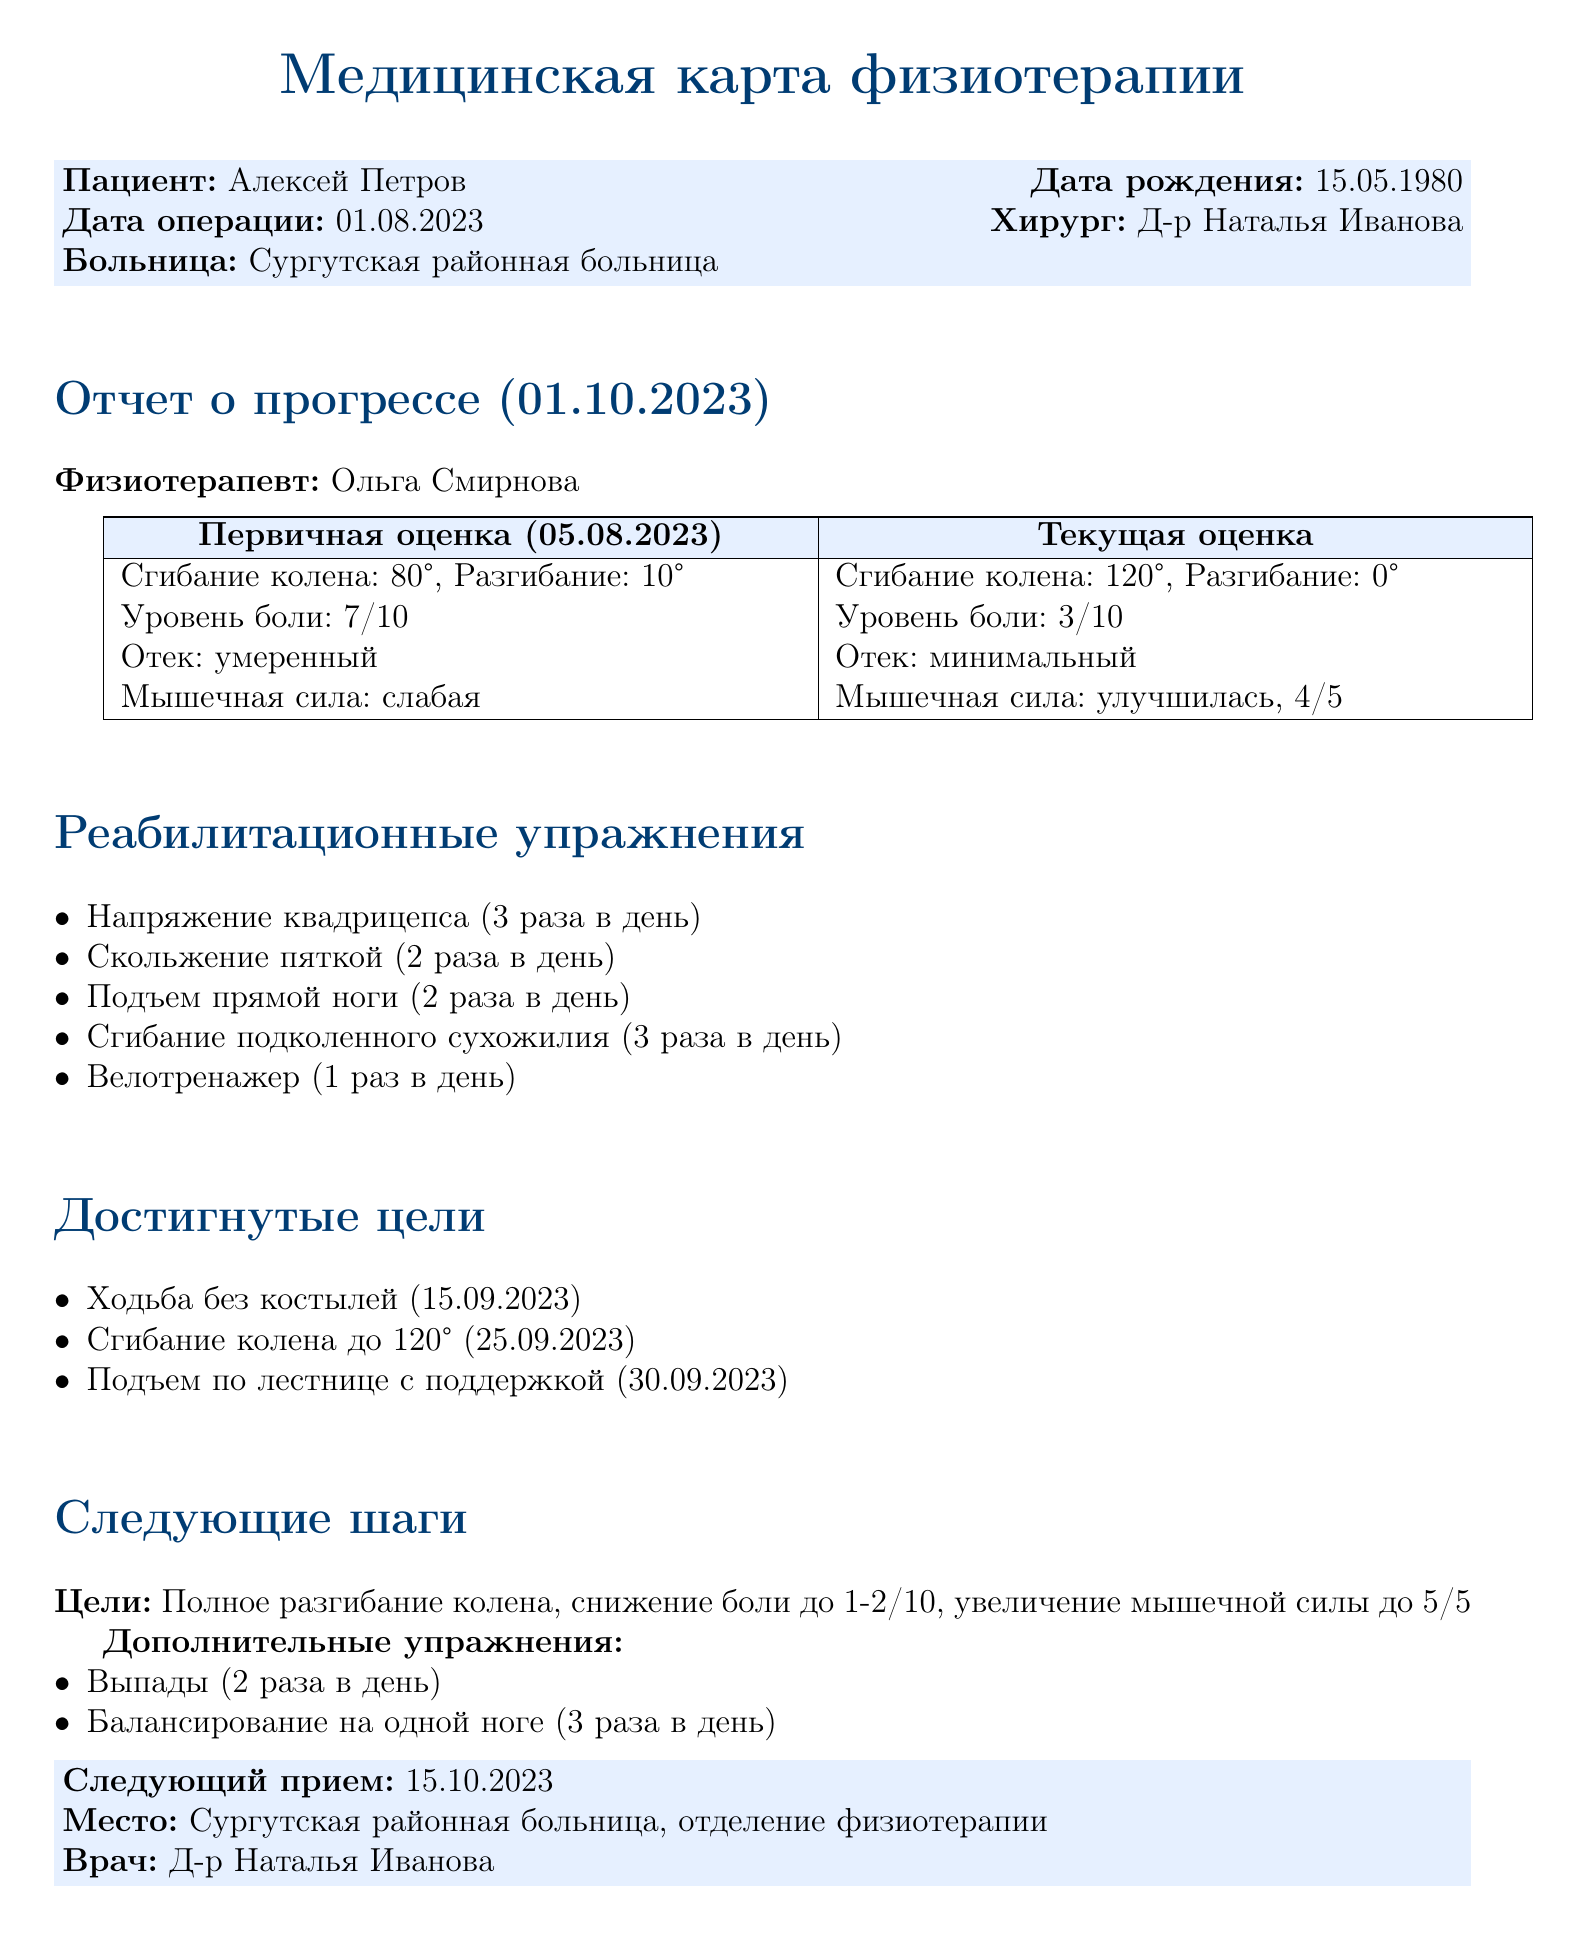Что имя пациента? Имя пациента указано в блоке с информацией о пациенте.
Answer: Алексей Петров Какова дата операции? Дата операции указана в информации о пациенте.
Answer: 01.08.2023 Какой хирург выполнил операцию? Имя хирурга указано в блоке с информацией о пациенте.
Answer: Д-р Наталья Иванова Каков уровень боли на текущей оценке? Уровень боли на текущей оценке указан в таблице.
Answer: 3/10 Какие два новых упражнения добавлены в следующие шаги? Новые упражнения указаны в разделе "Дополнительные упражнения".
Answer: Выпады, Балансирование на одной ноге Какова цель по разгибанию колена? Цель по разгибанию колена указана в разделе "Следующие шаги".
Answer: Полное разгибание колена Когда была достигнута цель по сгибанию колена до 120°? Дата достижения цели указана в разделе "Достигнутые цели".
Answer: 25.09.2023 Какова текущая мышечная сила пациента? Текущая мышечная сила указана в таблице.
Answer: 4/5 Какой следующий приём? Информация о следующем приёме указана в блоке с информацией после отчёта.
Answer: 15.10.2023 